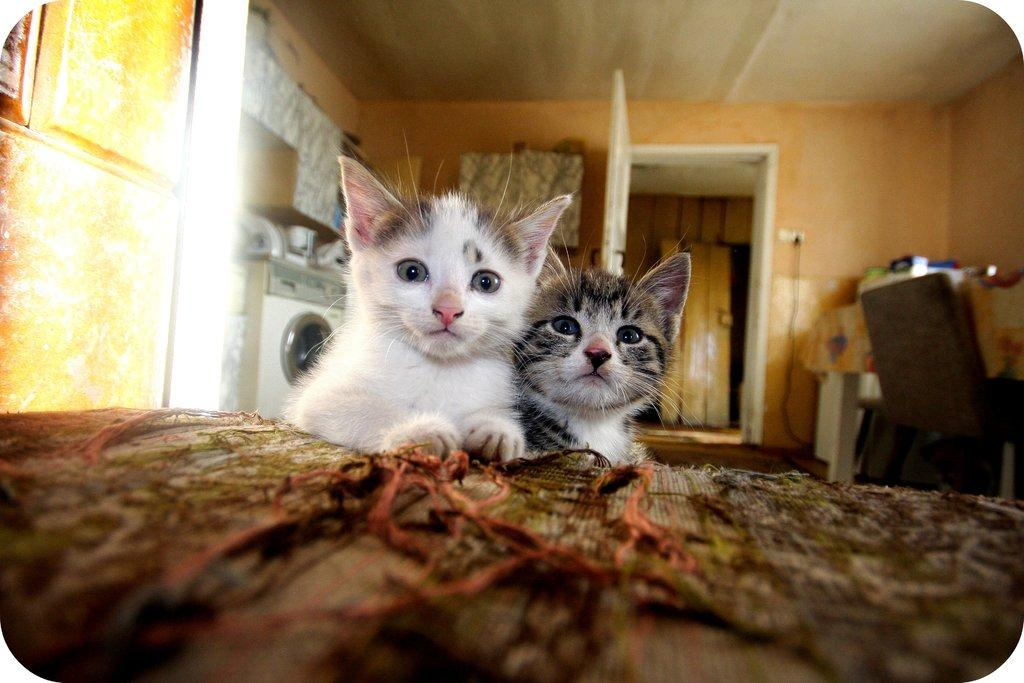How many cats are present in the image? There are 2 cats in the image. What type of appliance can be seen in the image? There is a washing machine in the image. What architectural feature is visible in the image? There is a door in the image. What type of structure is present in the image? There is a wall in the image. What type of furniture is present in the image? There is a chair in the image. What type of fire can be seen burning in the image? There is no fire present in the image. What type of gate can be seen in the image? There is no gate present in the image. What type of slope can be seen in the image? There is no slope present in the image. 